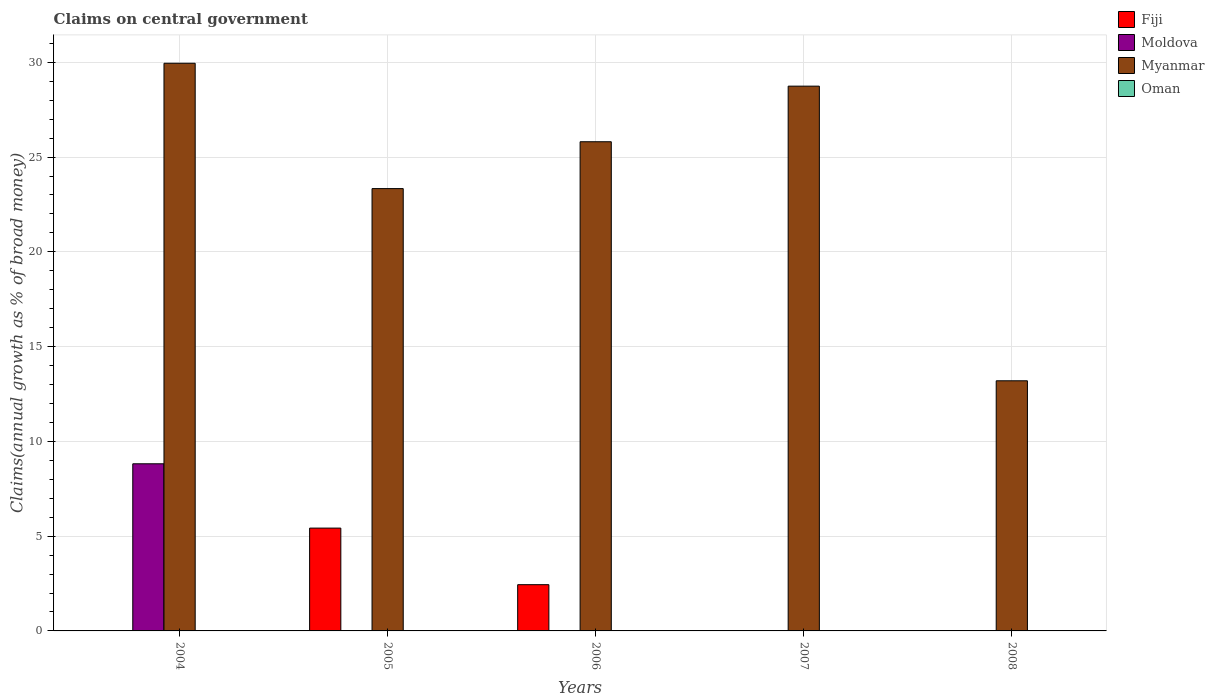How many different coloured bars are there?
Your answer should be very brief. 3. Are the number of bars per tick equal to the number of legend labels?
Provide a short and direct response. No. In how many cases, is the number of bars for a given year not equal to the number of legend labels?
Provide a succinct answer. 5. What is the percentage of broad money claimed on centeral government in Moldova in 2004?
Your response must be concise. 8.82. Across all years, what is the maximum percentage of broad money claimed on centeral government in Moldova?
Your answer should be compact. 8.82. Across all years, what is the minimum percentage of broad money claimed on centeral government in Myanmar?
Offer a very short reply. 13.2. What is the total percentage of broad money claimed on centeral government in Myanmar in the graph?
Ensure brevity in your answer.  121.03. What is the difference between the percentage of broad money claimed on centeral government in Myanmar in 2007 and that in 2008?
Keep it short and to the point. 15.54. What is the difference between the percentage of broad money claimed on centeral government in Oman in 2008 and the percentage of broad money claimed on centeral government in Myanmar in 2004?
Ensure brevity in your answer.  -29.95. What is the average percentage of broad money claimed on centeral government in Fiji per year?
Keep it short and to the point. 1.57. In how many years, is the percentage of broad money claimed on centeral government in Myanmar greater than 25 %?
Ensure brevity in your answer.  3. What is the ratio of the percentage of broad money claimed on centeral government in Myanmar in 2007 to that in 2008?
Provide a short and direct response. 2.18. What is the difference between the highest and the second highest percentage of broad money claimed on centeral government in Myanmar?
Ensure brevity in your answer.  1.21. What is the difference between the highest and the lowest percentage of broad money claimed on centeral government in Moldova?
Ensure brevity in your answer.  8.82. Is it the case that in every year, the sum of the percentage of broad money claimed on centeral government in Oman and percentage of broad money claimed on centeral government in Fiji is greater than the percentage of broad money claimed on centeral government in Moldova?
Your response must be concise. No. How many years are there in the graph?
Your response must be concise. 5. What is the difference between two consecutive major ticks on the Y-axis?
Your answer should be very brief. 5. Are the values on the major ticks of Y-axis written in scientific E-notation?
Your response must be concise. No. Does the graph contain grids?
Your answer should be compact. Yes. What is the title of the graph?
Provide a short and direct response. Claims on central government. What is the label or title of the Y-axis?
Offer a terse response. Claims(annual growth as % of broad money). What is the Claims(annual growth as % of broad money) in Fiji in 2004?
Offer a terse response. 0. What is the Claims(annual growth as % of broad money) in Moldova in 2004?
Offer a very short reply. 8.82. What is the Claims(annual growth as % of broad money) in Myanmar in 2004?
Make the answer very short. 29.95. What is the Claims(annual growth as % of broad money) in Oman in 2004?
Keep it short and to the point. 0. What is the Claims(annual growth as % of broad money) in Fiji in 2005?
Give a very brief answer. 5.42. What is the Claims(annual growth as % of broad money) in Myanmar in 2005?
Provide a succinct answer. 23.34. What is the Claims(annual growth as % of broad money) of Fiji in 2006?
Your answer should be very brief. 2.44. What is the Claims(annual growth as % of broad money) of Moldova in 2006?
Give a very brief answer. 0. What is the Claims(annual growth as % of broad money) in Myanmar in 2006?
Your answer should be compact. 25.81. What is the Claims(annual growth as % of broad money) in Oman in 2006?
Give a very brief answer. 0. What is the Claims(annual growth as % of broad money) in Moldova in 2007?
Offer a terse response. 0. What is the Claims(annual growth as % of broad money) of Myanmar in 2007?
Provide a succinct answer. 28.74. What is the Claims(annual growth as % of broad money) in Moldova in 2008?
Make the answer very short. 0. What is the Claims(annual growth as % of broad money) of Myanmar in 2008?
Make the answer very short. 13.2. What is the Claims(annual growth as % of broad money) in Oman in 2008?
Give a very brief answer. 0. Across all years, what is the maximum Claims(annual growth as % of broad money) of Fiji?
Provide a short and direct response. 5.42. Across all years, what is the maximum Claims(annual growth as % of broad money) in Moldova?
Offer a terse response. 8.82. Across all years, what is the maximum Claims(annual growth as % of broad money) in Myanmar?
Keep it short and to the point. 29.95. Across all years, what is the minimum Claims(annual growth as % of broad money) in Fiji?
Keep it short and to the point. 0. Across all years, what is the minimum Claims(annual growth as % of broad money) in Moldova?
Offer a terse response. 0. Across all years, what is the minimum Claims(annual growth as % of broad money) of Myanmar?
Ensure brevity in your answer.  13.2. What is the total Claims(annual growth as % of broad money) of Fiji in the graph?
Your answer should be very brief. 7.86. What is the total Claims(annual growth as % of broad money) of Moldova in the graph?
Ensure brevity in your answer.  8.82. What is the total Claims(annual growth as % of broad money) in Myanmar in the graph?
Provide a succinct answer. 121.03. What is the total Claims(annual growth as % of broad money) in Oman in the graph?
Keep it short and to the point. 0. What is the difference between the Claims(annual growth as % of broad money) of Myanmar in 2004 and that in 2005?
Your response must be concise. 6.61. What is the difference between the Claims(annual growth as % of broad money) in Myanmar in 2004 and that in 2006?
Your answer should be compact. 4.14. What is the difference between the Claims(annual growth as % of broad money) in Myanmar in 2004 and that in 2007?
Provide a succinct answer. 1.21. What is the difference between the Claims(annual growth as % of broad money) in Myanmar in 2004 and that in 2008?
Keep it short and to the point. 16.75. What is the difference between the Claims(annual growth as % of broad money) in Fiji in 2005 and that in 2006?
Your answer should be very brief. 2.99. What is the difference between the Claims(annual growth as % of broad money) in Myanmar in 2005 and that in 2006?
Give a very brief answer. -2.47. What is the difference between the Claims(annual growth as % of broad money) of Myanmar in 2005 and that in 2007?
Keep it short and to the point. -5.41. What is the difference between the Claims(annual growth as % of broad money) in Myanmar in 2005 and that in 2008?
Make the answer very short. 10.14. What is the difference between the Claims(annual growth as % of broad money) of Myanmar in 2006 and that in 2007?
Ensure brevity in your answer.  -2.93. What is the difference between the Claims(annual growth as % of broad money) in Myanmar in 2006 and that in 2008?
Your answer should be compact. 12.61. What is the difference between the Claims(annual growth as % of broad money) in Myanmar in 2007 and that in 2008?
Your response must be concise. 15.54. What is the difference between the Claims(annual growth as % of broad money) in Moldova in 2004 and the Claims(annual growth as % of broad money) in Myanmar in 2005?
Provide a succinct answer. -14.52. What is the difference between the Claims(annual growth as % of broad money) of Moldova in 2004 and the Claims(annual growth as % of broad money) of Myanmar in 2006?
Your answer should be very brief. -16.99. What is the difference between the Claims(annual growth as % of broad money) of Moldova in 2004 and the Claims(annual growth as % of broad money) of Myanmar in 2007?
Offer a very short reply. -19.92. What is the difference between the Claims(annual growth as % of broad money) in Moldova in 2004 and the Claims(annual growth as % of broad money) in Myanmar in 2008?
Make the answer very short. -4.38. What is the difference between the Claims(annual growth as % of broad money) in Fiji in 2005 and the Claims(annual growth as % of broad money) in Myanmar in 2006?
Provide a succinct answer. -20.38. What is the difference between the Claims(annual growth as % of broad money) in Fiji in 2005 and the Claims(annual growth as % of broad money) in Myanmar in 2007?
Provide a short and direct response. -23.32. What is the difference between the Claims(annual growth as % of broad money) in Fiji in 2005 and the Claims(annual growth as % of broad money) in Myanmar in 2008?
Keep it short and to the point. -7.77. What is the difference between the Claims(annual growth as % of broad money) of Fiji in 2006 and the Claims(annual growth as % of broad money) of Myanmar in 2007?
Offer a very short reply. -26.3. What is the difference between the Claims(annual growth as % of broad money) of Fiji in 2006 and the Claims(annual growth as % of broad money) of Myanmar in 2008?
Give a very brief answer. -10.76. What is the average Claims(annual growth as % of broad money) of Fiji per year?
Provide a succinct answer. 1.57. What is the average Claims(annual growth as % of broad money) of Moldova per year?
Your response must be concise. 1.76. What is the average Claims(annual growth as % of broad money) in Myanmar per year?
Offer a very short reply. 24.21. What is the average Claims(annual growth as % of broad money) in Oman per year?
Give a very brief answer. 0. In the year 2004, what is the difference between the Claims(annual growth as % of broad money) in Moldova and Claims(annual growth as % of broad money) in Myanmar?
Your answer should be compact. -21.13. In the year 2005, what is the difference between the Claims(annual growth as % of broad money) in Fiji and Claims(annual growth as % of broad money) in Myanmar?
Your answer should be compact. -17.91. In the year 2006, what is the difference between the Claims(annual growth as % of broad money) of Fiji and Claims(annual growth as % of broad money) of Myanmar?
Your response must be concise. -23.37. What is the ratio of the Claims(annual growth as % of broad money) of Myanmar in 2004 to that in 2005?
Make the answer very short. 1.28. What is the ratio of the Claims(annual growth as % of broad money) in Myanmar in 2004 to that in 2006?
Keep it short and to the point. 1.16. What is the ratio of the Claims(annual growth as % of broad money) of Myanmar in 2004 to that in 2007?
Your response must be concise. 1.04. What is the ratio of the Claims(annual growth as % of broad money) in Myanmar in 2004 to that in 2008?
Provide a succinct answer. 2.27. What is the ratio of the Claims(annual growth as % of broad money) of Fiji in 2005 to that in 2006?
Offer a very short reply. 2.22. What is the ratio of the Claims(annual growth as % of broad money) of Myanmar in 2005 to that in 2006?
Offer a very short reply. 0.9. What is the ratio of the Claims(annual growth as % of broad money) of Myanmar in 2005 to that in 2007?
Keep it short and to the point. 0.81. What is the ratio of the Claims(annual growth as % of broad money) of Myanmar in 2005 to that in 2008?
Provide a succinct answer. 1.77. What is the ratio of the Claims(annual growth as % of broad money) of Myanmar in 2006 to that in 2007?
Offer a very short reply. 0.9. What is the ratio of the Claims(annual growth as % of broad money) in Myanmar in 2006 to that in 2008?
Make the answer very short. 1.96. What is the ratio of the Claims(annual growth as % of broad money) in Myanmar in 2007 to that in 2008?
Ensure brevity in your answer.  2.18. What is the difference between the highest and the second highest Claims(annual growth as % of broad money) of Myanmar?
Make the answer very short. 1.21. What is the difference between the highest and the lowest Claims(annual growth as % of broad money) in Fiji?
Your response must be concise. 5.42. What is the difference between the highest and the lowest Claims(annual growth as % of broad money) of Moldova?
Keep it short and to the point. 8.82. What is the difference between the highest and the lowest Claims(annual growth as % of broad money) in Myanmar?
Make the answer very short. 16.75. 